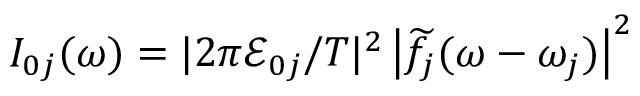Convert formula to latex. <formula><loc_0><loc_0><loc_500><loc_500>I _ { 0 j } ( \omega ) = | 2 \pi \mathcal { E } _ { 0 j } / T | ^ { 2 } \left | \widetilde { f } _ { j } ( \omega - \omega _ { j } ) \right | ^ { 2 }</formula> 